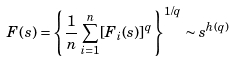Convert formula to latex. <formula><loc_0><loc_0><loc_500><loc_500>F ( s ) = \left \{ \frac { 1 } { n } \sum _ { i = 1 } ^ { n } [ F _ { i } ( s ) ] ^ { q } \right \} ^ { 1 / q } \sim s ^ { h ( q ) }</formula> 